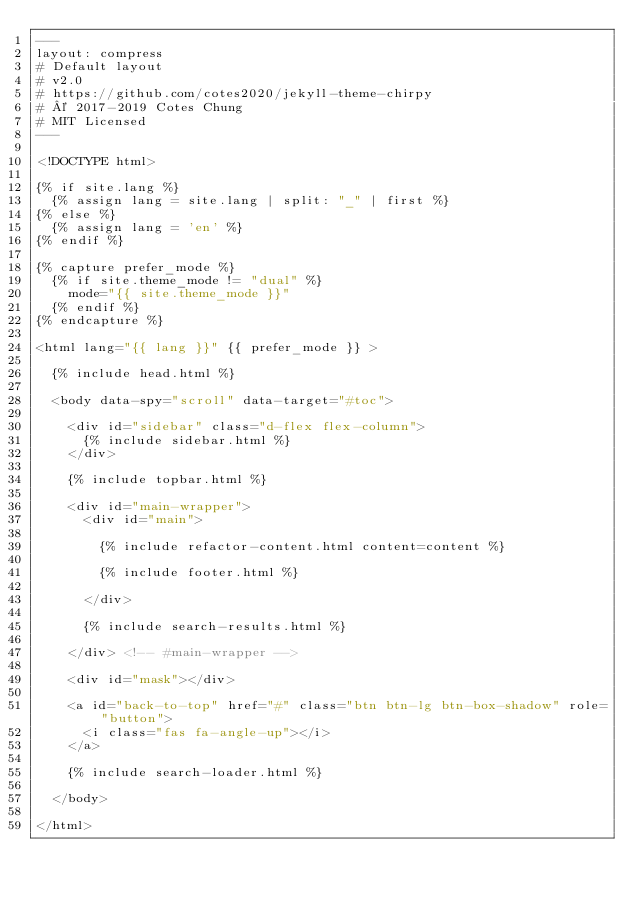Convert code to text. <code><loc_0><loc_0><loc_500><loc_500><_HTML_>---
layout: compress
# Default layout
# v2.0
# https://github.com/cotes2020/jekyll-theme-chirpy
# © 2017-2019 Cotes Chung
# MIT Licensed
---

<!DOCTYPE html>

{% if site.lang %}
  {% assign lang = site.lang | split: "_" | first %}
{% else %}
  {% assign lang = 'en' %}
{% endif %}

{% capture prefer_mode %}
  {% if site.theme_mode != "dual" %}
    mode="{{ site.theme_mode }}"
  {% endif %}
{% endcapture %}

<html lang="{{ lang }}" {{ prefer_mode }} >

  {% include head.html %}

  <body data-spy="scroll" data-target="#toc">

    <div id="sidebar" class="d-flex flex-column">
      {% include sidebar.html %}
    </div>

    {% include topbar.html %}

    <div id="main-wrapper">
      <div id="main">

        {% include refactor-content.html content=content %}

        {% include footer.html %}

      </div>

      {% include search-results.html %}

    </div> <!-- #main-wrapper -->

    <div id="mask"></div>

    <a id="back-to-top" href="#" class="btn btn-lg btn-box-shadow" role="button">
      <i class="fas fa-angle-up"></i>
    </a>

    {% include search-loader.html %}

  </body>

</html>
</code> 